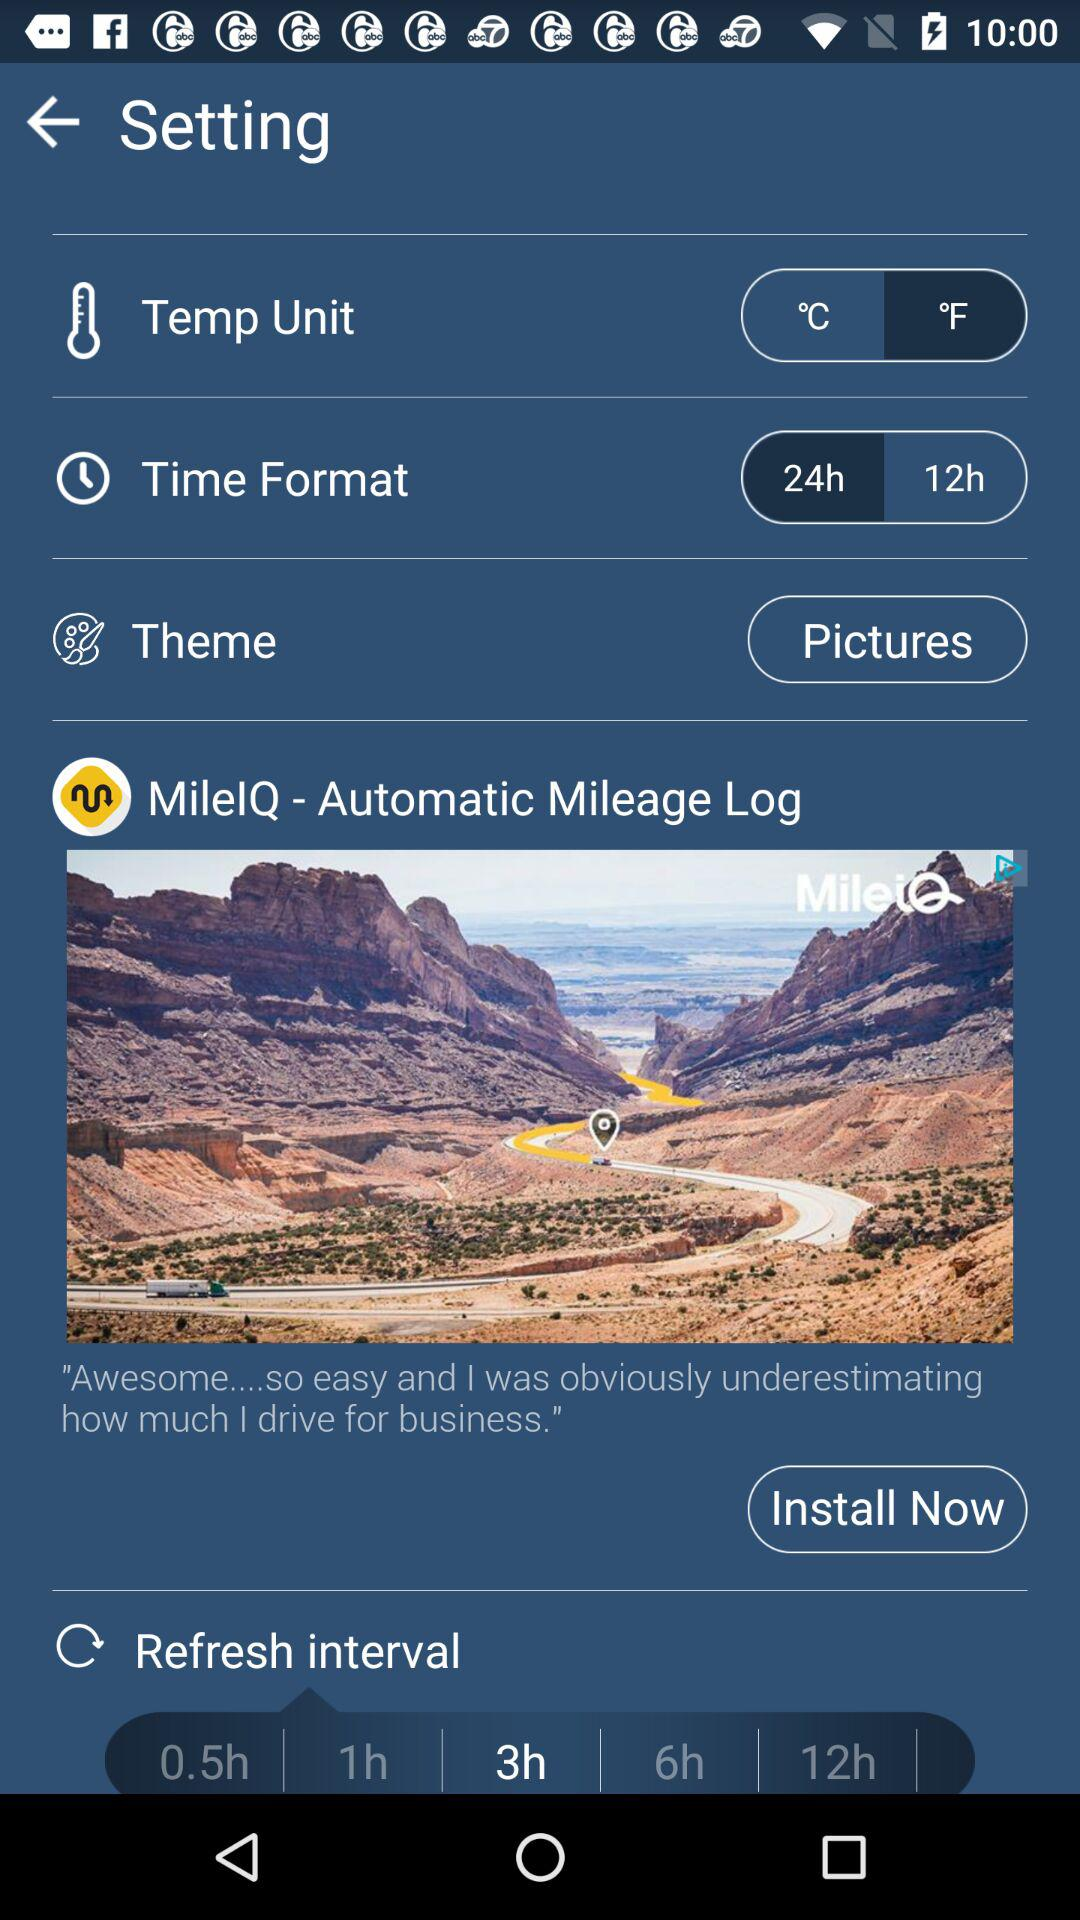What is the selected refresh interval? The selected refresh interval is 3 hours. 